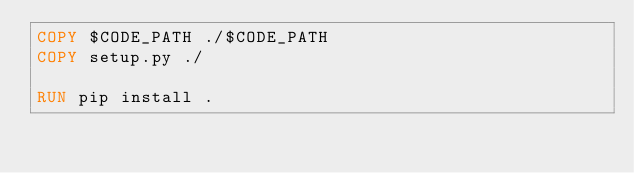<code> <loc_0><loc_0><loc_500><loc_500><_Dockerfile_>COPY $CODE_PATH ./$CODE_PATH
COPY setup.py ./

RUN pip install .
</code> 